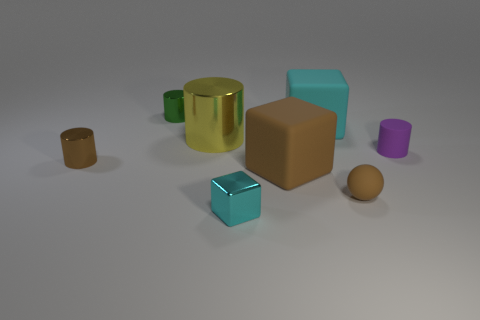There is a tiny cylinder that is both in front of the big cyan object and left of the tiny rubber ball; what is its material?
Ensure brevity in your answer.  Metal. How many big cyan objects are the same shape as the small cyan metal thing?
Your response must be concise. 1. The cylinder on the right side of the metal object in front of the small brown cylinder is what color?
Provide a succinct answer. Purple. Is the number of tiny purple matte cylinders on the left side of the small cyan metal object the same as the number of tiny green cylinders?
Your answer should be compact. No. Is there a yellow metallic thing of the same size as the sphere?
Your answer should be very brief. No. Do the yellow metallic cylinder and the shiny object in front of the large brown object have the same size?
Your answer should be very brief. No. Is the number of tiny purple cylinders in front of the brown ball the same as the number of green shiny things in front of the large cyan cube?
Offer a very short reply. Yes. There is a matte object that is the same color as the matte sphere; what is its shape?
Your response must be concise. Cube. There is a cyan thing in front of the purple object; what is its material?
Offer a terse response. Metal. Does the rubber sphere have the same size as the yellow thing?
Your answer should be compact. No. 